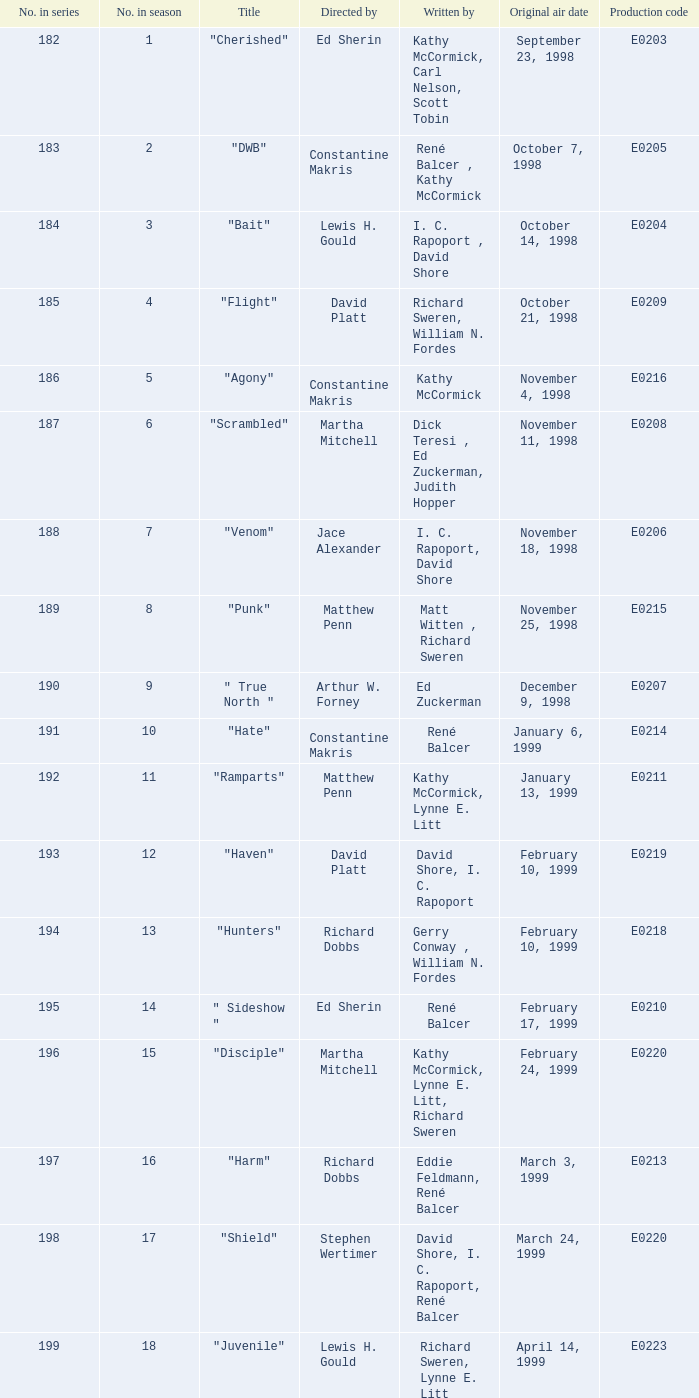The episode that first aired on january 6, 1999, possesses which production code? E0214. 